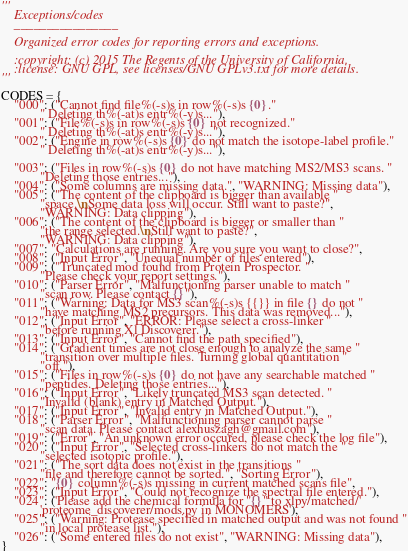<code> <loc_0><loc_0><loc_500><loc_500><_Python_>'''
    Exceptions/codes
    ________________

    Organized error codes for reporting errors and exceptions.

    :copyright: (c) 2015 The Regents of the University of California.
    :license: GNU GPL, see licenses/GNU GPLv3.txt for more details.
'''

CODES = {
    "000": ("Cannot find file%(-s)s in row%(-s)s {0}."
            " Deleting th%(-at)s entr%(-y)s..."),
    "001": ("File%(-s)s in row%(-s)s {0} not recognized."
            " Deleting th%(-at)s entr%(-y)s..."),
    "002": ("Engine in row%(-s)s {0} do not match the isotope-label profile."
            " Deleting th%(-at)s entr%(-y)s..."),

    "003": ("Files in row%(-s)s {0} do not have matching MS2/MS3 scans. "
            "Deleting those entries..."),
    "004": ("Some columns are missing data.", "WARNING: Missing data"),
    "005": ("The content of the clipboard is bigger than available "
            "space.\nSome data loss will occur. Still want to paste?",
            "WARNING: Data clipping"),
    "006": ("The content of the clipboard is bigger or smaller than "
            "the range selected.\nStill want to paste?",
            "WARNING: Data clipping"),
    "007": "Calculations are running. Are you sure you want to close?",
    "008": ("Input Error", "Unequal number of files entered"),
    "009": ("Truncated mod found from Protein Prospector. "
            "Please check your report settings."),
    "010": ("Parser Error", "Malfunctioning parser unable to match "
            "scan row. Please contact {}"),
    "011": ("Warning: Data for MS3 scan%(-s)s {{}} in file {} do not "
            "have matching MS2 precursors. This data was removed..."),
    "012": ("Input Error", "ERROR: Please select a cross-linker "
            "before running Xl Discoverer."),
    "013": ("Input Error", "Cannot find the path specified"),
    "014": ("Gradient times are not close enough to analyze the same "
            "transition over multiple files. Turning global quantitation "
            "off."),
    "015": ("Files in row%(-s)s {0} do not have any searchable matched "
            "peptides. Deleting those entries..."),
    "016": ("Input Error", "Likely truncated MS3 scan detected. "
            "Invalid (blank) entry in Matched Output."),
    "017": ("Input Error", "Invalid entry in Matched Output."),
    "018": ("Parser Error", "Malfunctioning parser cannot parse "
            "scan data. Please contact alexhuszagh@gmail.com"),
    "019": ("Error", "An unknown error occured, please check the log file"),
    "020": ("Input Error", "Selected cross-linkers do not match the "
            "selected isotopic profile."),
    "021": ("The sort data does not exist in the transitions "
            "file and therefore cannot be sorted.", "Sorting Error"),
    "022": "{0} column%(-s)s missing in current matched scans file",
    "023": ("Input Error", "Could not recognize the spectral file entered."),
    "024": ('Please add the chemical formula for "{}" to xlpy/matched/'
            'proteome_discoverer/mods.py in MONOMERS'),
    "025": ("Warning: Protease specified in matched output and was not found "
            "in local protease list."),
    "026": ("Some entered files do not exist", "WARNING: Missing data"),
}
</code> 